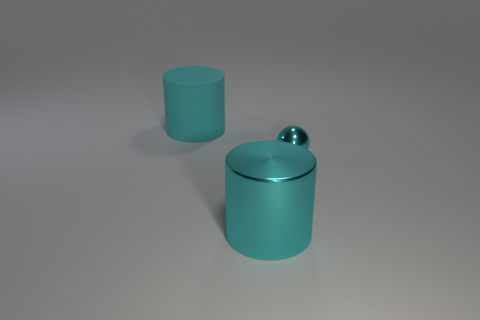Add 2 large green matte objects. How many objects exist? 5 Add 1 large cyan rubber cylinders. How many large cyan rubber cylinders are left? 2 Add 2 green blocks. How many green blocks exist? 2 Subtract 0 brown cylinders. How many objects are left? 3 Subtract all balls. How many objects are left? 2 Subtract all large metal spheres. Subtract all small cyan metal things. How many objects are left? 2 